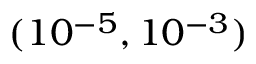Convert formula to latex. <formula><loc_0><loc_0><loc_500><loc_500>( 1 0 ^ { - 5 } , 1 0 ^ { - 3 } )</formula> 